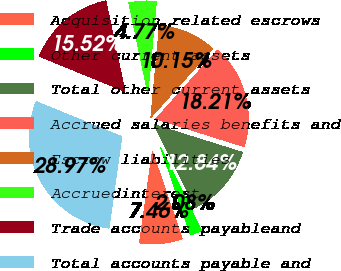Convert chart to OTSL. <chart><loc_0><loc_0><loc_500><loc_500><pie_chart><fcel>Acquisition related escrows<fcel>Other current assets<fcel>Total other current assets<fcel>Accrued salaries benefits and<fcel>Escrow liabilities<fcel>Accruedinterest<fcel>Trade accounts payableand<fcel>Total accounts payable and<nl><fcel>7.46%<fcel>2.08%<fcel>12.84%<fcel>18.21%<fcel>10.15%<fcel>4.77%<fcel>15.52%<fcel>28.97%<nl></chart> 